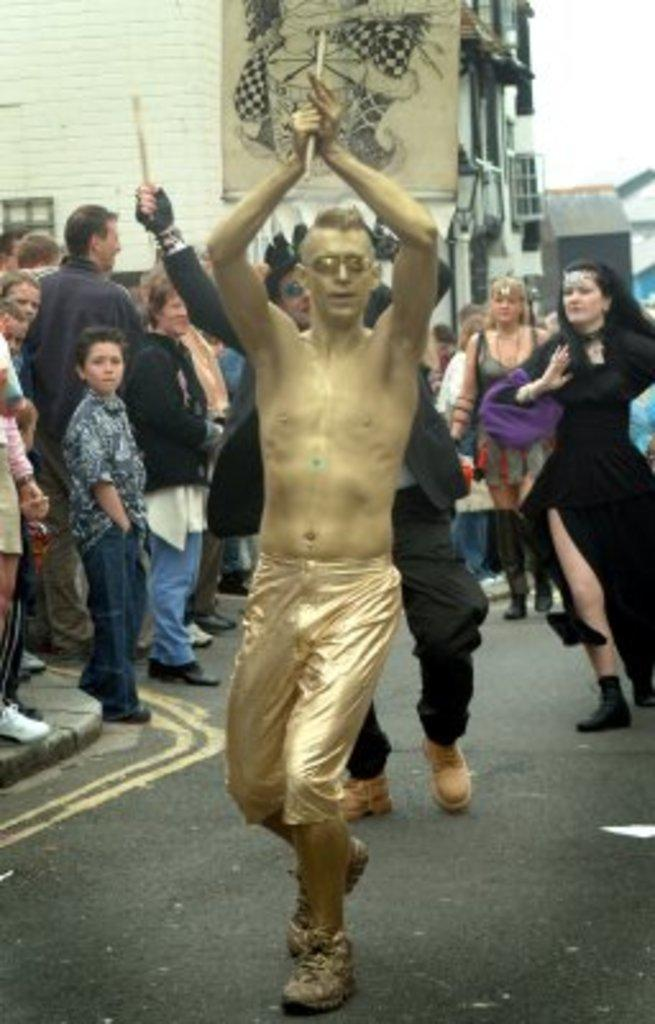How many people are in the group that is visible in the image? There is a group of people in the image, but the exact number is not specified. What are some of the people holding in the image? Some people are holding objects in the image, but the specific objects are not described. Where are the people performing in the image? The people are performing on the road in the image. What can be seen in the background of the image? In the background of the image, there are buildings, walls, a banner, and other objects. What type of plastic is used to make the company's authority visible in the image? There is no mention of a company or authority in the image, nor is there any reference to plastic. 